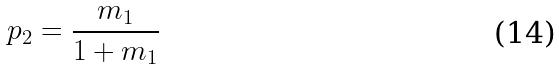Convert formula to latex. <formula><loc_0><loc_0><loc_500><loc_500>p _ { 2 } = \frac { m _ { 1 } } { 1 + m _ { 1 } }</formula> 